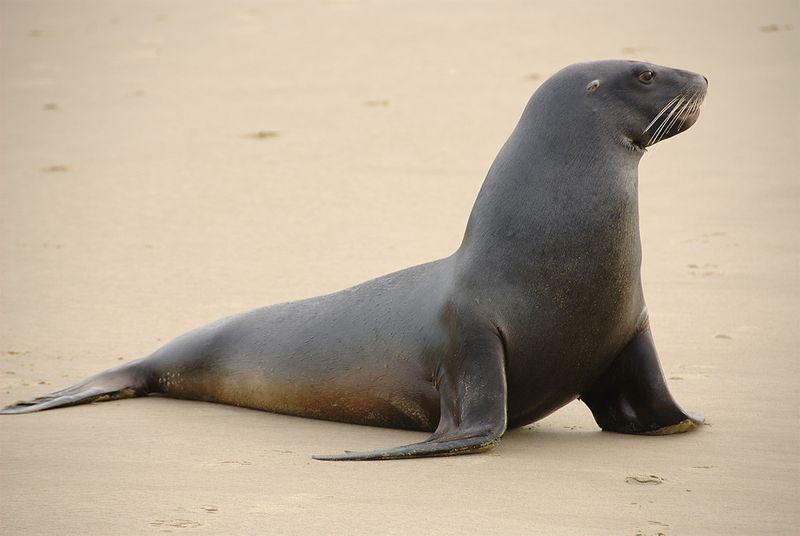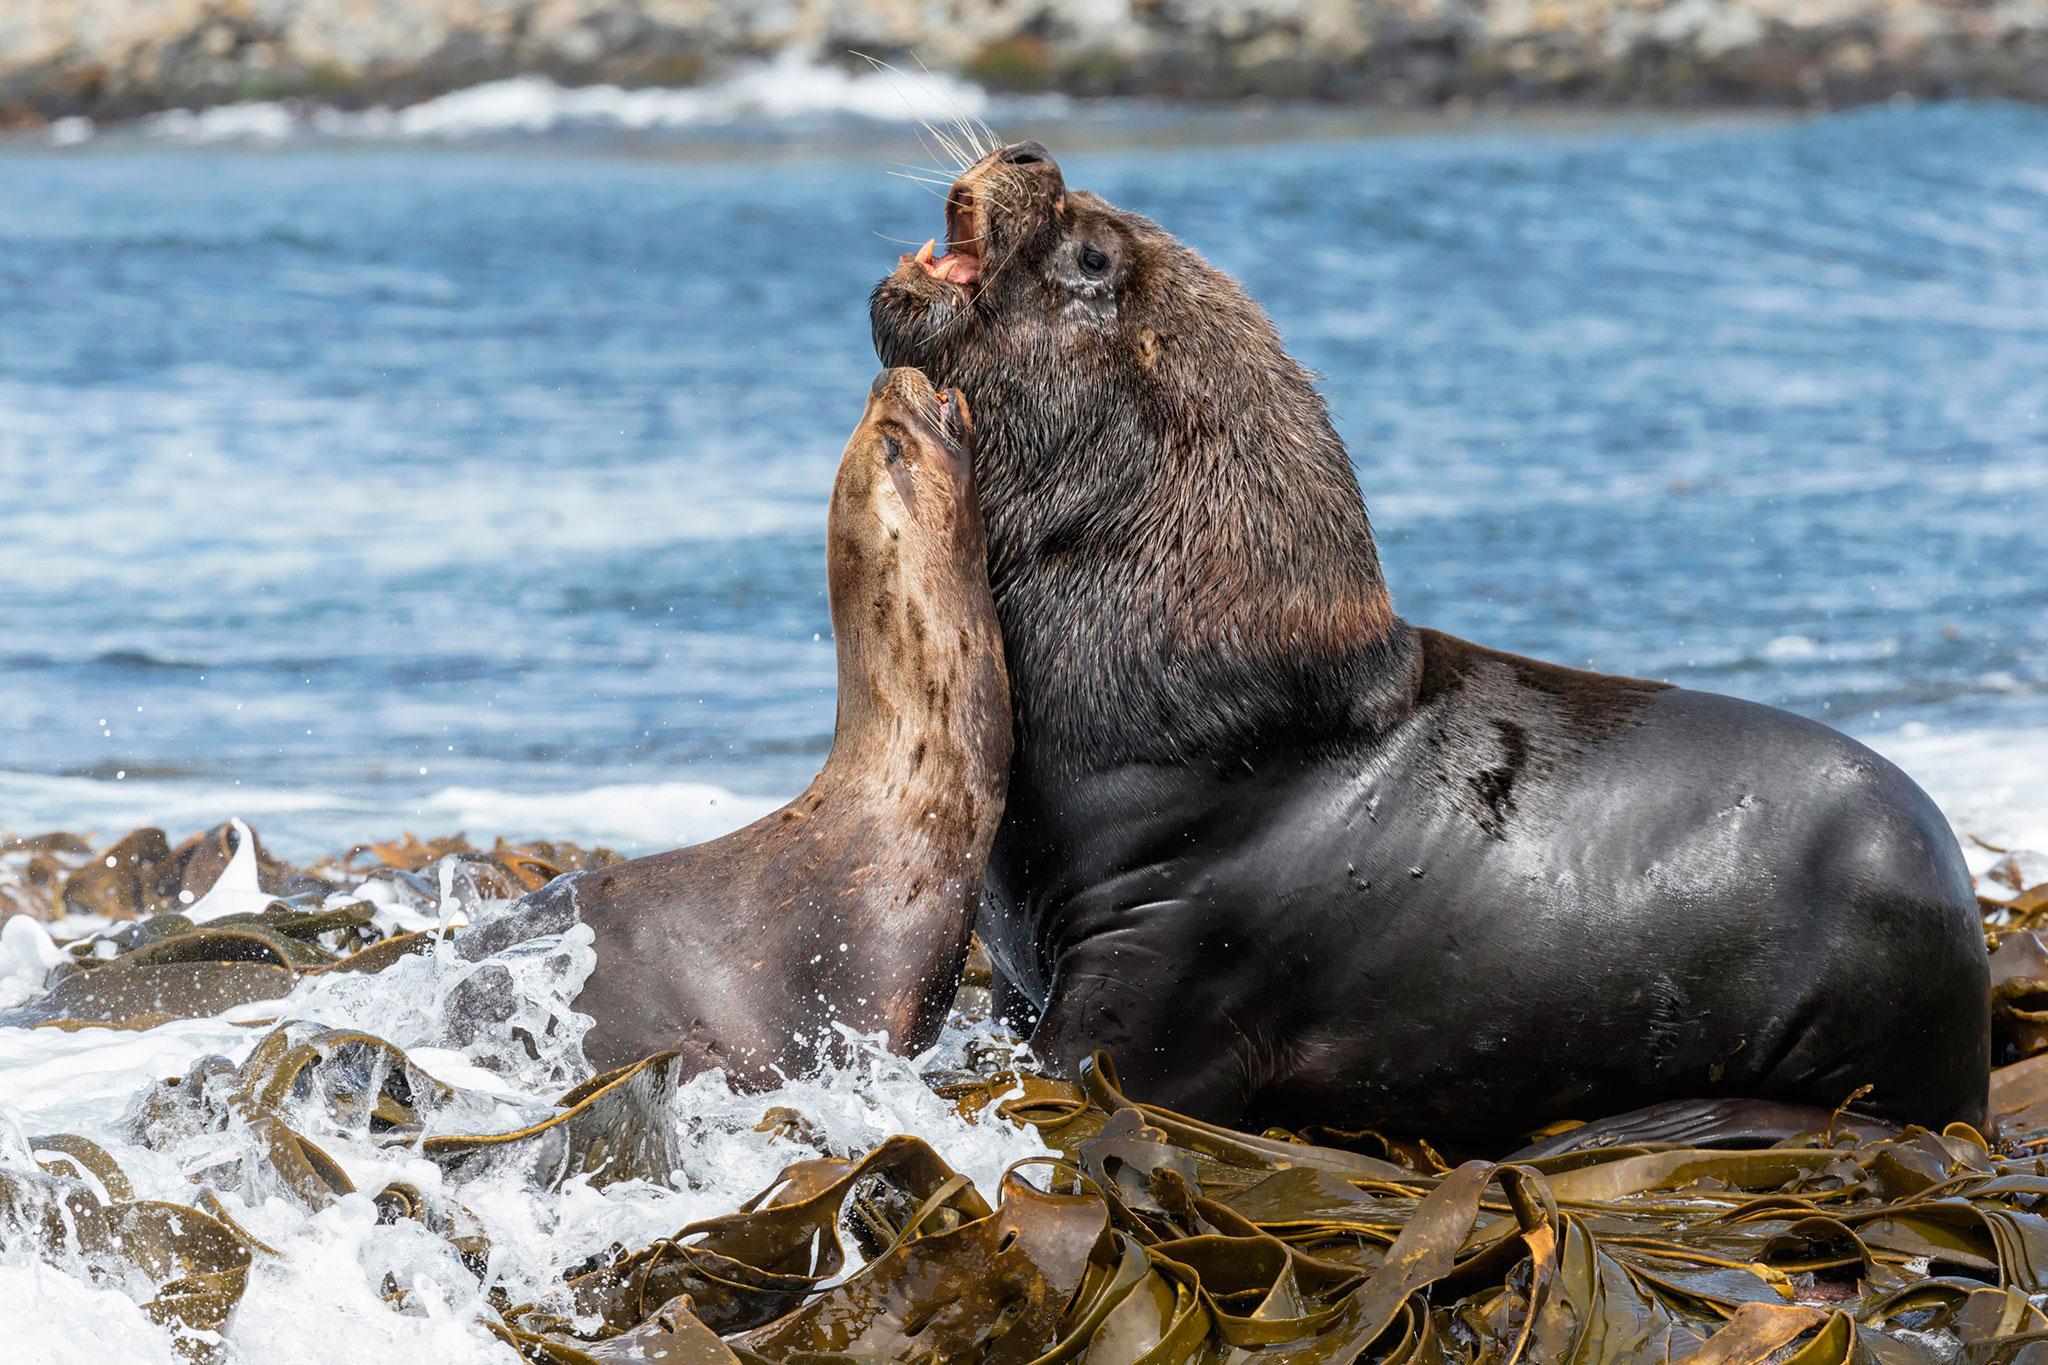The first image is the image on the left, the second image is the image on the right. Examine the images to the left and right. Is the description "The left image depicts a young seal which is not black." accurate? Answer yes or no. No. 